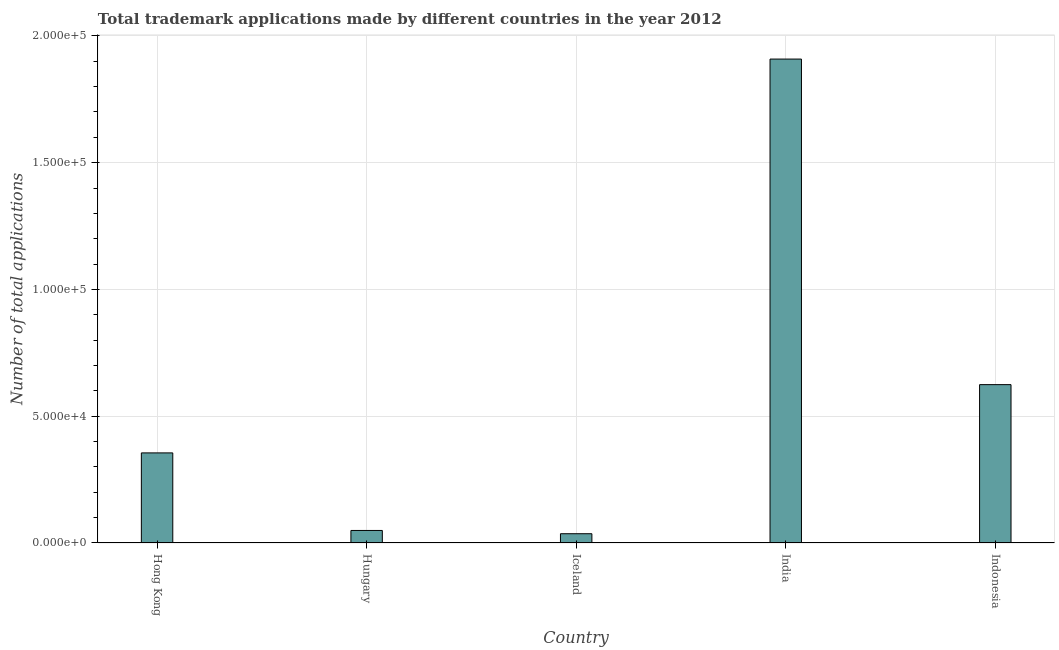Does the graph contain any zero values?
Make the answer very short. No. What is the title of the graph?
Ensure brevity in your answer.  Total trademark applications made by different countries in the year 2012. What is the label or title of the Y-axis?
Keep it short and to the point. Number of total applications. What is the number of trademark applications in Indonesia?
Provide a succinct answer. 6.25e+04. Across all countries, what is the maximum number of trademark applications?
Give a very brief answer. 1.91e+05. Across all countries, what is the minimum number of trademark applications?
Give a very brief answer. 3655. In which country was the number of trademark applications maximum?
Offer a very short reply. India. What is the sum of the number of trademark applications?
Make the answer very short. 2.97e+05. What is the difference between the number of trademark applications in Iceland and Indonesia?
Provide a short and direct response. -5.88e+04. What is the average number of trademark applications per country?
Your answer should be very brief. 5.95e+04. What is the median number of trademark applications?
Provide a succinct answer. 3.55e+04. What is the ratio of the number of trademark applications in Hungary to that in India?
Offer a very short reply. 0.03. What is the difference between the highest and the second highest number of trademark applications?
Keep it short and to the point. 1.28e+05. Is the sum of the number of trademark applications in Hungary and Iceland greater than the maximum number of trademark applications across all countries?
Your response must be concise. No. What is the difference between the highest and the lowest number of trademark applications?
Offer a very short reply. 1.87e+05. In how many countries, is the number of trademark applications greater than the average number of trademark applications taken over all countries?
Make the answer very short. 2. How many bars are there?
Offer a very short reply. 5. How many countries are there in the graph?
Your answer should be very brief. 5. Are the values on the major ticks of Y-axis written in scientific E-notation?
Make the answer very short. Yes. What is the Number of total applications of Hong Kong?
Provide a succinct answer. 3.55e+04. What is the Number of total applications in Hungary?
Offer a terse response. 4939. What is the Number of total applications of Iceland?
Your response must be concise. 3655. What is the Number of total applications of India?
Offer a very short reply. 1.91e+05. What is the Number of total applications of Indonesia?
Keep it short and to the point. 6.25e+04. What is the difference between the Number of total applications in Hong Kong and Hungary?
Your answer should be compact. 3.06e+04. What is the difference between the Number of total applications in Hong Kong and Iceland?
Make the answer very short. 3.19e+04. What is the difference between the Number of total applications in Hong Kong and India?
Provide a succinct answer. -1.55e+05. What is the difference between the Number of total applications in Hong Kong and Indonesia?
Offer a very short reply. -2.69e+04. What is the difference between the Number of total applications in Hungary and Iceland?
Offer a terse response. 1284. What is the difference between the Number of total applications in Hungary and India?
Ensure brevity in your answer.  -1.86e+05. What is the difference between the Number of total applications in Hungary and Indonesia?
Provide a succinct answer. -5.75e+04. What is the difference between the Number of total applications in Iceland and India?
Your response must be concise. -1.87e+05. What is the difference between the Number of total applications in Iceland and Indonesia?
Give a very brief answer. -5.88e+04. What is the difference between the Number of total applications in India and Indonesia?
Provide a succinct answer. 1.28e+05. What is the ratio of the Number of total applications in Hong Kong to that in Hungary?
Offer a very short reply. 7.19. What is the ratio of the Number of total applications in Hong Kong to that in Iceland?
Make the answer very short. 9.72. What is the ratio of the Number of total applications in Hong Kong to that in India?
Keep it short and to the point. 0.19. What is the ratio of the Number of total applications in Hong Kong to that in Indonesia?
Provide a succinct answer. 0.57. What is the ratio of the Number of total applications in Hungary to that in Iceland?
Keep it short and to the point. 1.35. What is the ratio of the Number of total applications in Hungary to that in India?
Offer a terse response. 0.03. What is the ratio of the Number of total applications in Hungary to that in Indonesia?
Give a very brief answer. 0.08. What is the ratio of the Number of total applications in Iceland to that in India?
Offer a terse response. 0.02. What is the ratio of the Number of total applications in Iceland to that in Indonesia?
Offer a terse response. 0.06. What is the ratio of the Number of total applications in India to that in Indonesia?
Provide a succinct answer. 3.06. 